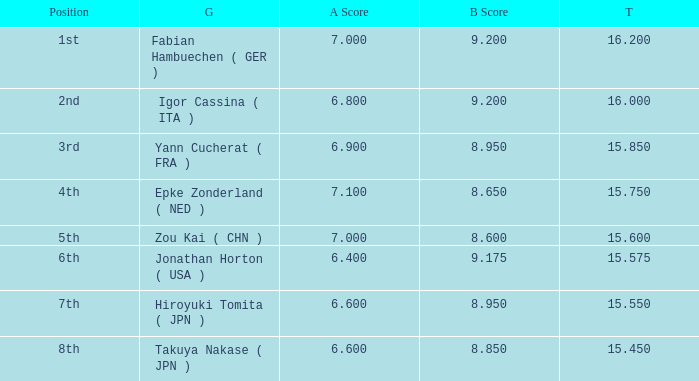What was the total rating that had a score higher than 7 and a b score smaller than 8.65? None. 